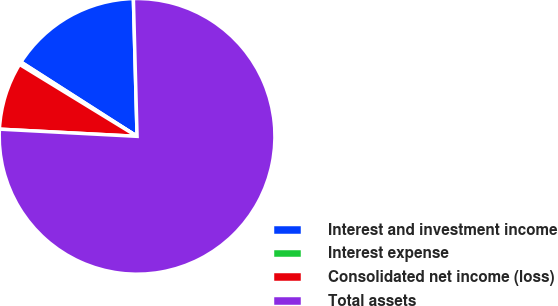Convert chart. <chart><loc_0><loc_0><loc_500><loc_500><pie_chart><fcel>Interest and investment income<fcel>Interest expense<fcel>Consolidated net income (loss)<fcel>Total assets<nl><fcel>15.51%<fcel>0.32%<fcel>7.91%<fcel>76.26%<nl></chart> 